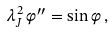Convert formula to latex. <formula><loc_0><loc_0><loc_500><loc_500>\lambda _ { J } ^ { 2 } \, \varphi ^ { \prime \prime } = \sin \varphi \, ,</formula> 